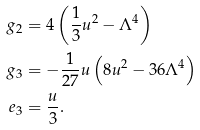<formula> <loc_0><loc_0><loc_500><loc_500>g _ { 2 } & = 4 \left ( \frac { 1 } { 3 } u ^ { 2 } - \Lambda ^ { 4 } \right ) \\ g _ { 3 } & = - \frac { 1 } { 2 7 } u \left ( 8 u ^ { 2 } - 3 6 \Lambda ^ { 4 } \right ) \\ e _ { 3 } & = \frac { u } { 3 } .</formula> 